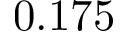<formula> <loc_0><loc_0><loc_500><loc_500>0 . 1 7 5</formula> 